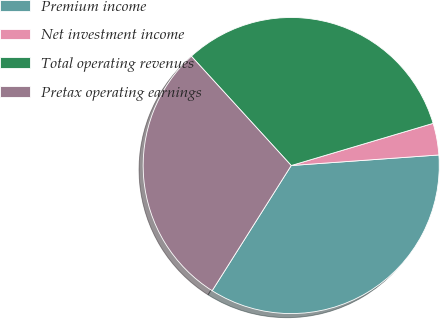Convert chart to OTSL. <chart><loc_0><loc_0><loc_500><loc_500><pie_chart><fcel>Premium income<fcel>Net investment income<fcel>Total operating revenues<fcel>Pretax operating earnings<nl><fcel>35.1%<fcel>3.46%<fcel>32.18%<fcel>29.25%<nl></chart> 